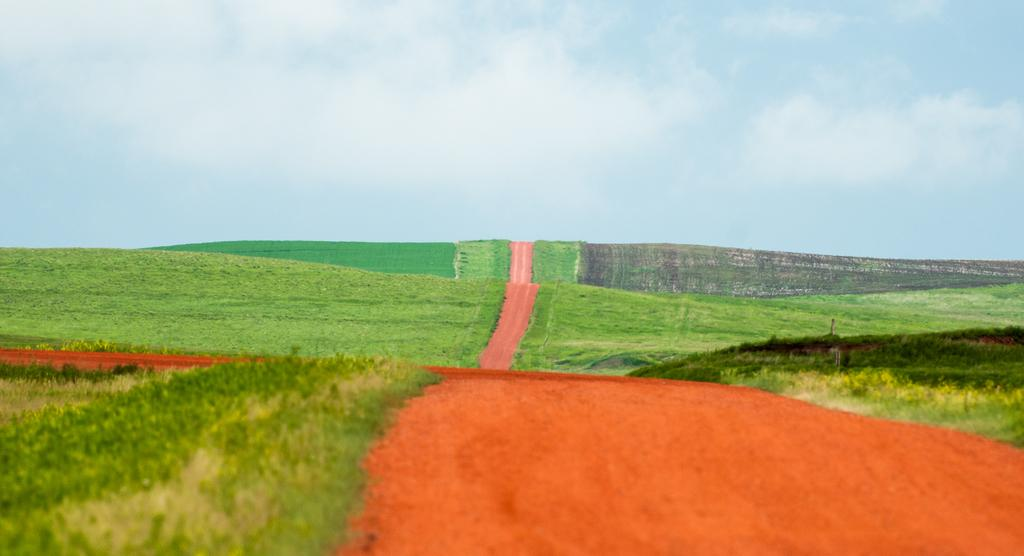What type of terrain is visible in the image? There is an open grass ground in the image. Is there any specific feature on the grass ground? Yes, there is a path in the center of the grass ground. What can be seen in the background of the image? Clouds and the sky are visible in the background of the image. Where is the mom selling fruits in the image? There is no mom or fruit stand present in the image. What trick is being performed on the grass ground in the image? There is no trick or performance taking place on the grass ground in the image. 